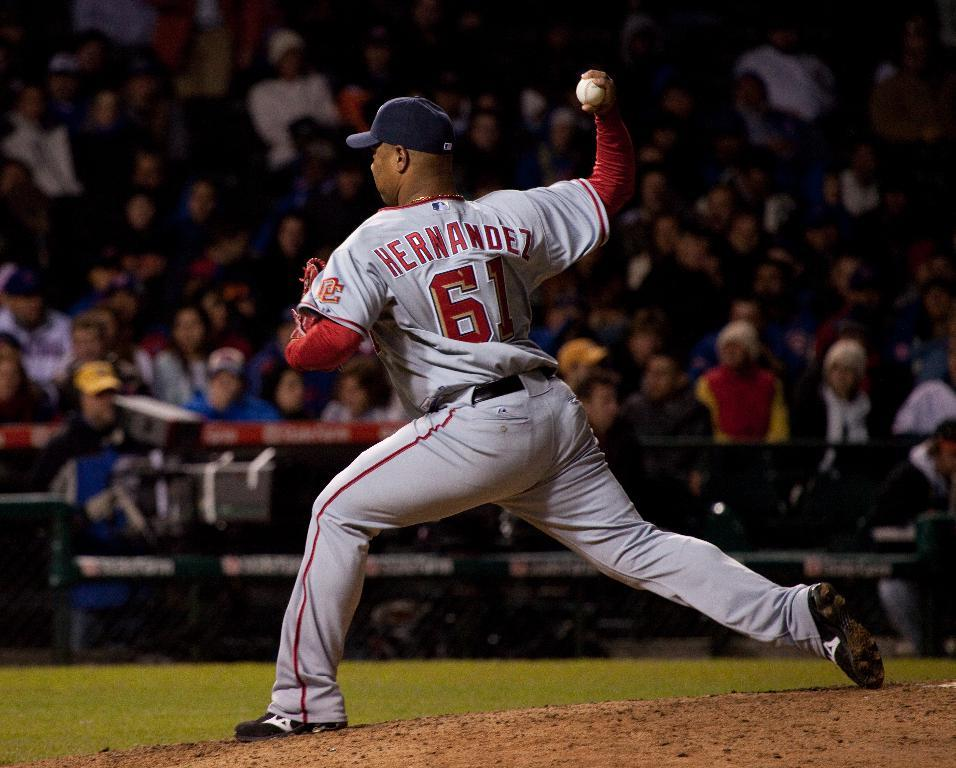<image>
Share a concise interpretation of the image provided. Baseball pitcher named Hernandez wearing a jersey with the number 61. 